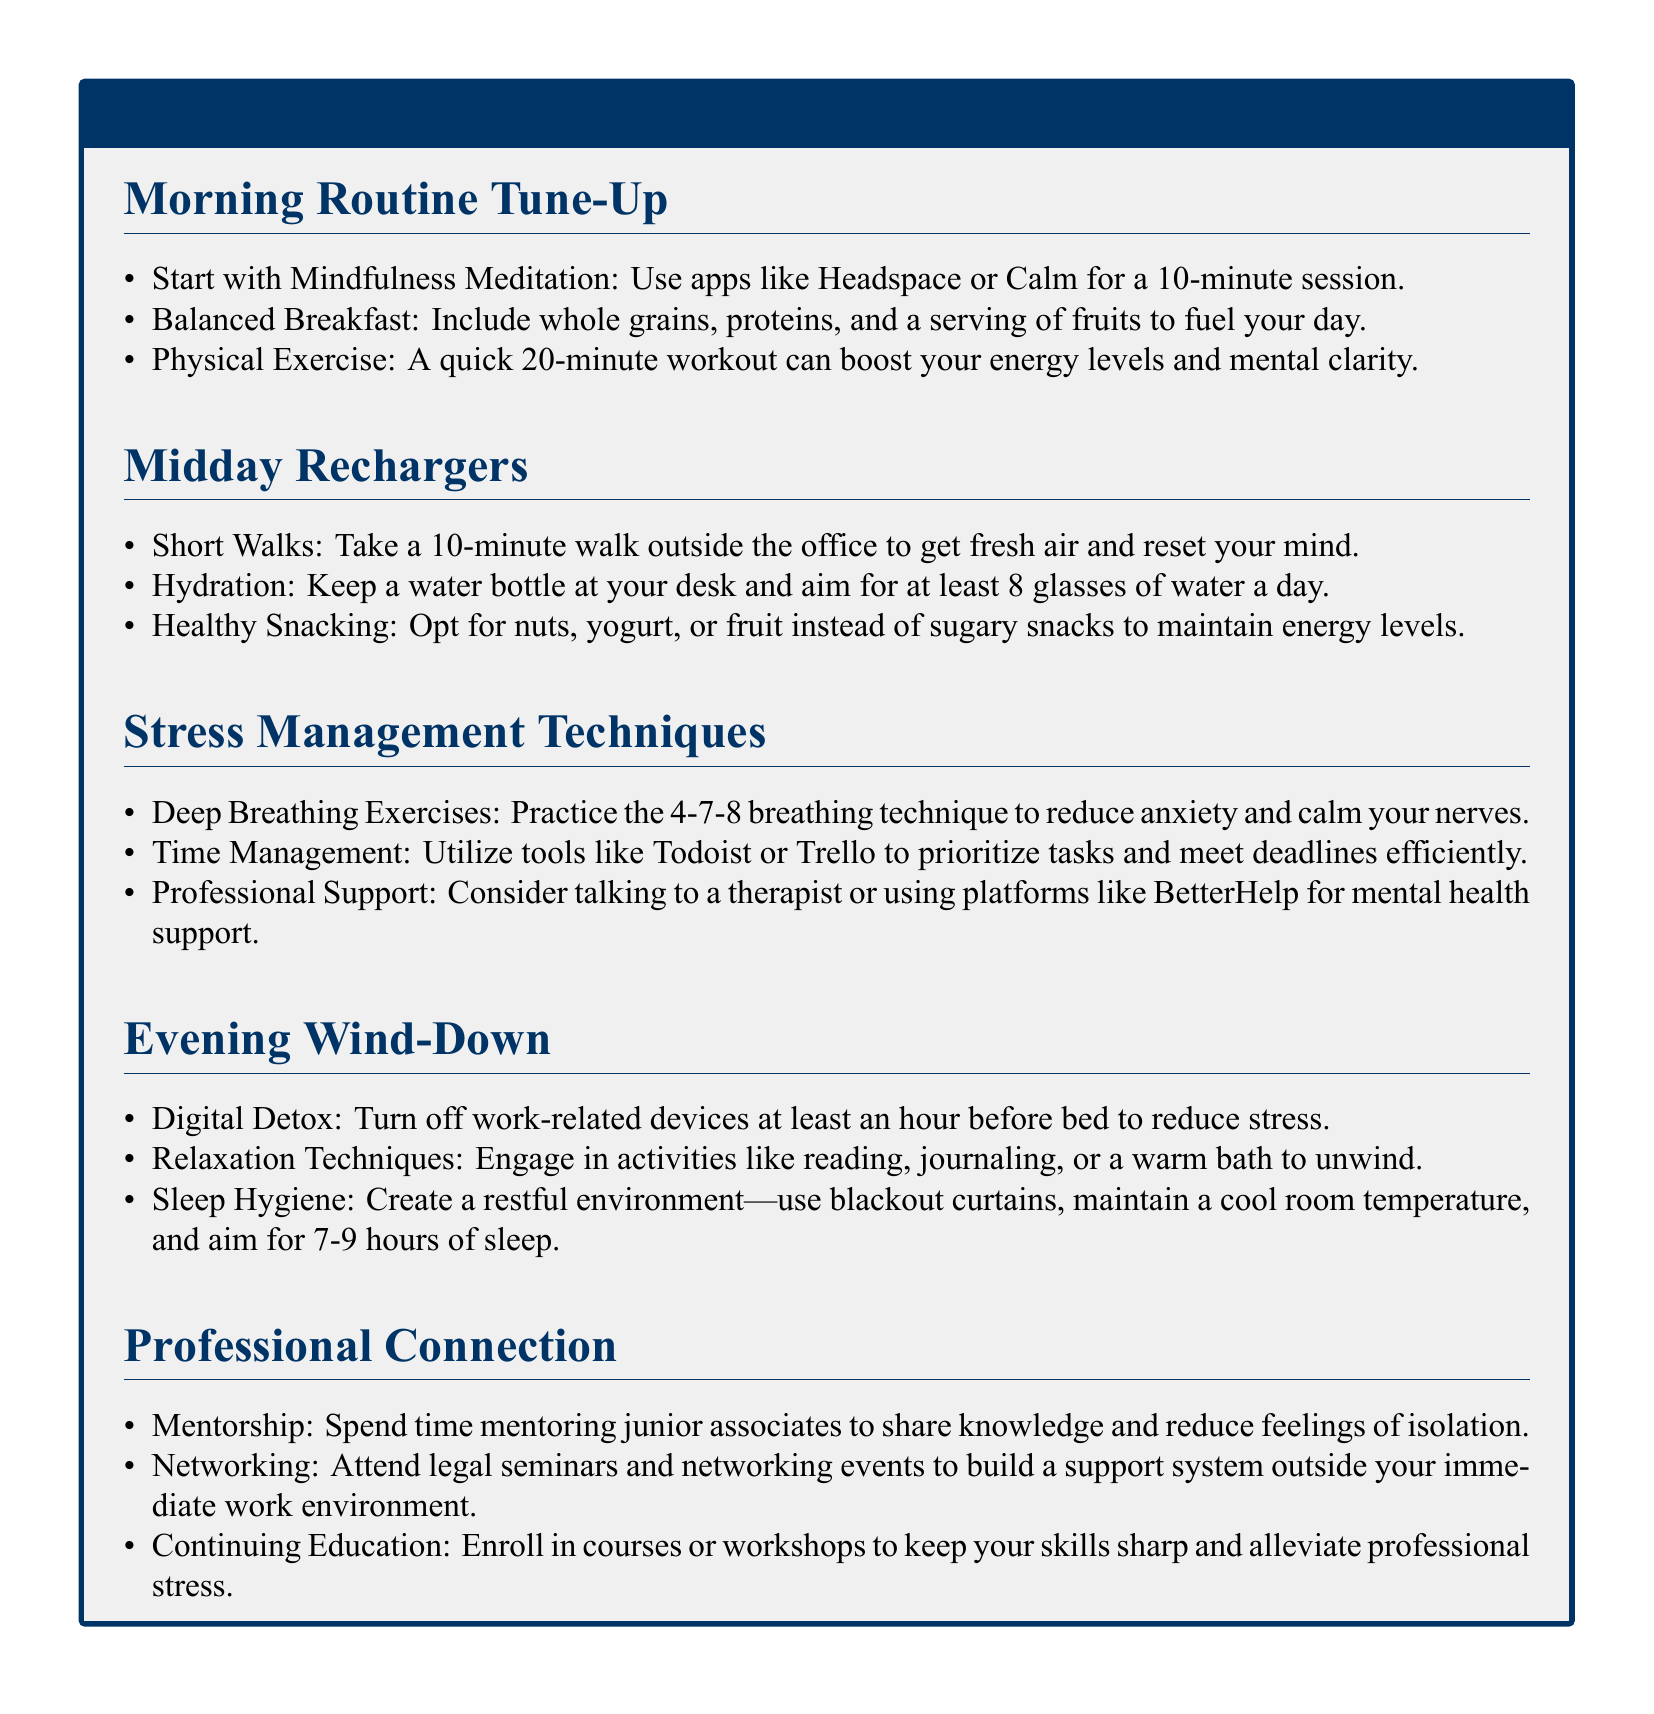What is the recommended duration for mindfulness meditation? The document states a 10-minute session for mindfulness meditation.
Answer: 10 minutes What is suggested to be included in a balanced breakfast? The document lists whole grains, proteins, and a serving of fruits.
Answer: Whole grains, proteins, fruits How long should a quick workout be to boost energy? The document recommends a quick workout of 20 minutes.
Answer: 20 minutes What breathing technique is suggested for reducing anxiety? The technique mentioned in the document is the 4-7-8 breathing technique.
Answer: 4-7-8 breathing technique What is the aim for daily water intake? The document advises aiming for at least 8 glasses of water a day.
Answer: 8 glasses What is one relaxation technique recommended for the evening? The document mentions activities like reading, journaling, or a warm bath.
Answer: Reading, journaling, warm bath What type of professional support is suggested in the document? The document suggests talking to a therapist or using platforms like BetterHelp.
Answer: Therapist or BetterHelp How many hours of sleep are recommended for good sleep hygiene? The document recommends aiming for 7-9 hours of sleep.
Answer: 7-9 hours What is one professional connection activity to reduce feelings of isolation? The document mentions spending time mentoring junior associates.
Answer: Mentoring junior associates 